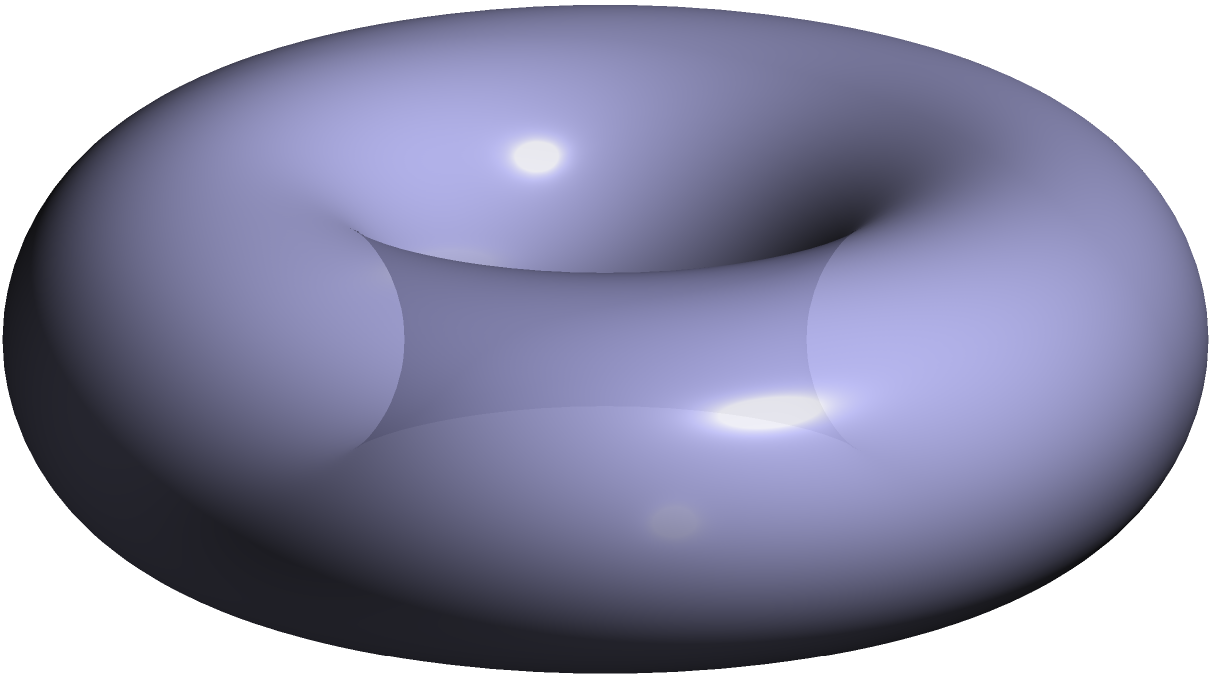On a torus representing global childbirth practices, a geodesic path symbolizes the journey of a travel blogger documenting birth experiences across cultures. If the torus has a major radius $R=2$ and a minor radius $r=1$, what is the approximate length of the shortest closed geodesic that wraps around the torus both longitudinally and latitudinally? To find the length of the shortest closed geodesic on a torus that wraps around both longitudinally and latitudinally, we need to follow these steps:

1) The shortest such geodesic on a torus is known as the "diagonal" geodesic.

2) The length of this geodesic can be calculated using the formula:

   $$L = 2\pi\sqrt{R^2 + r^2}$$

   Where $R$ is the major radius and $r$ is the minor radius of the torus.

3) We are given that $R=2$ and $r=1$. Let's substitute these values:

   $$L = 2\pi\sqrt{2^2 + 1^2}$$

4) Simplify inside the square root:

   $$L = 2\pi\sqrt{4 + 1} = 2\pi\sqrt{5}$$

5) This cannot be simplified further without approximation. If we want to give a numerical approximation:

   $$L \approx 2\pi * 2.236 \approx 14.05$$

This length represents the shortest path that travels around the torus both longitudinally and latitudinally, symbolizing the cyclical nature of childbirth practices across different cultures as documented by the travel blogger.
Answer: $2\pi\sqrt{5}$ (or approximately 14.05) 